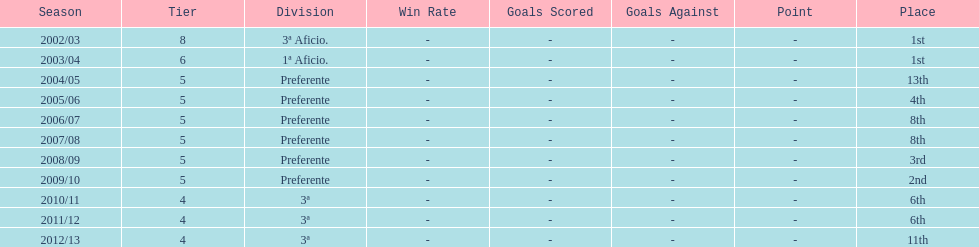Which division placed more than aficio 1a and 3a? Preferente. 